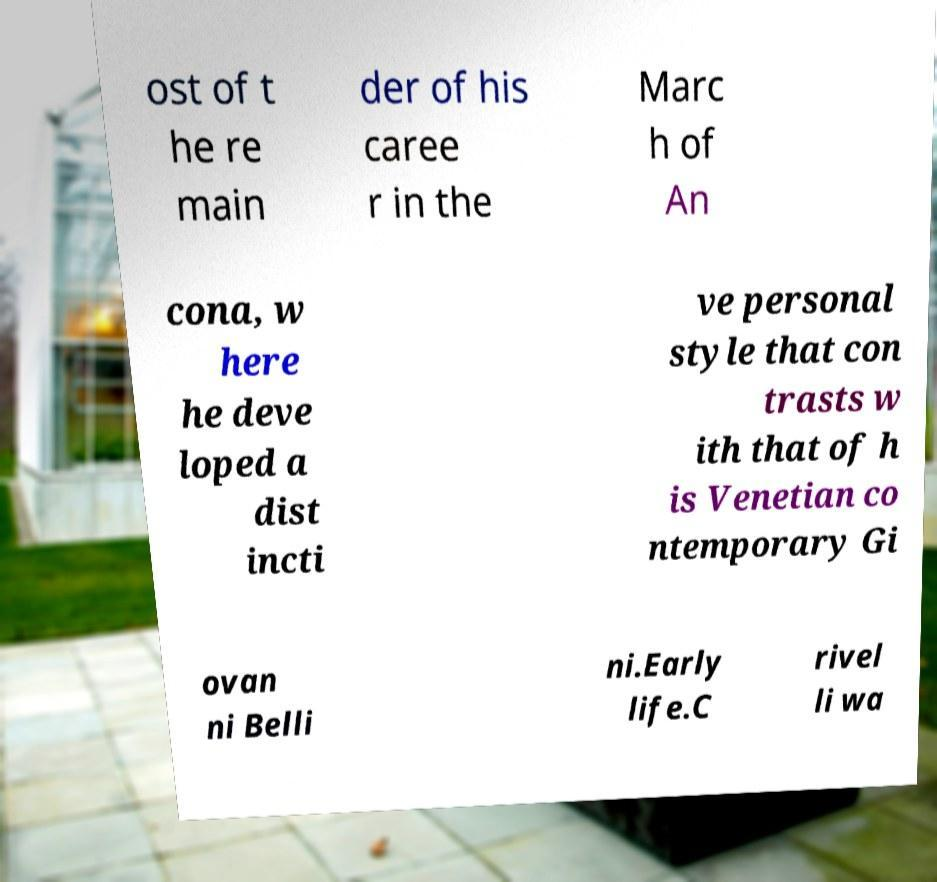There's text embedded in this image that I need extracted. Can you transcribe it verbatim? ost of t he re main der of his caree r in the Marc h of An cona, w here he deve loped a dist incti ve personal style that con trasts w ith that of h is Venetian co ntemporary Gi ovan ni Belli ni.Early life.C rivel li wa 